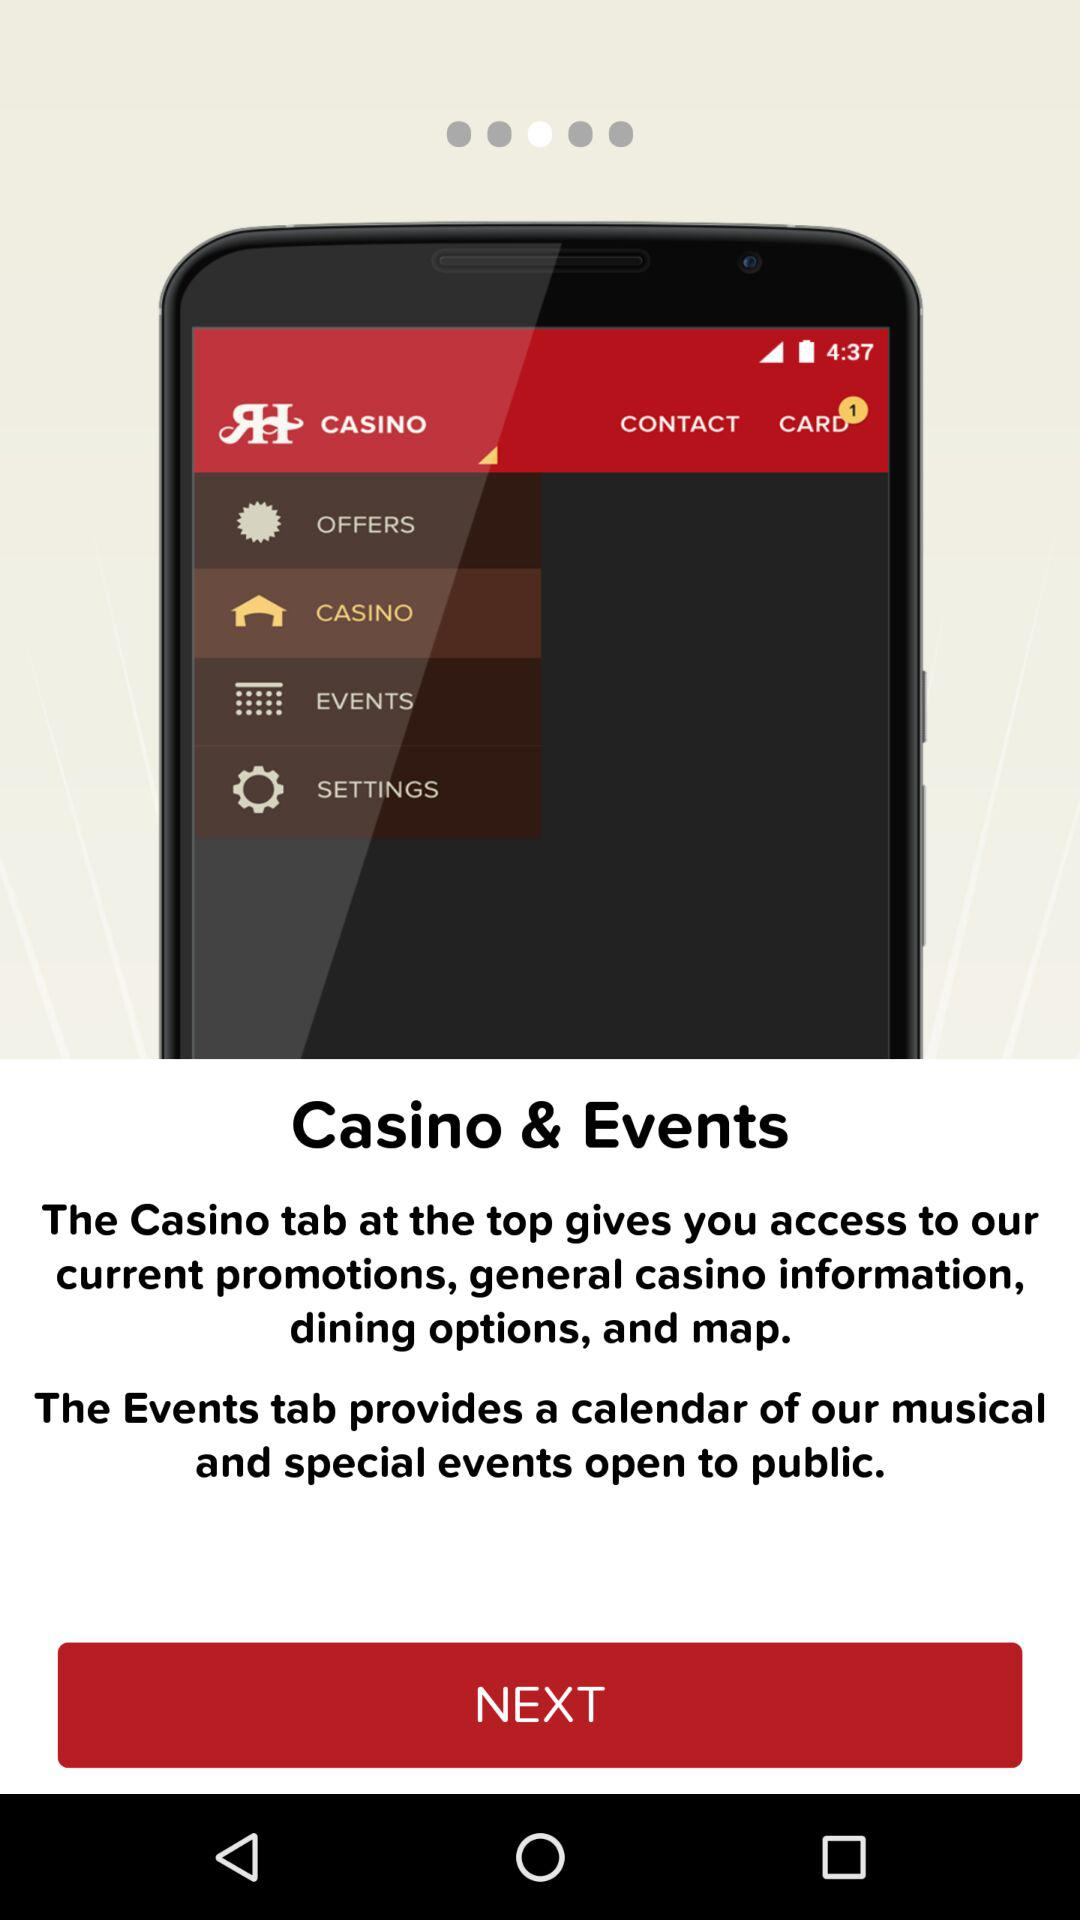How many tabs are there in the menu?
Answer the question using a single word or phrase. 2 